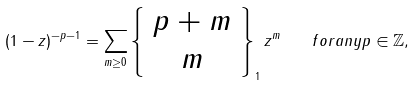Convert formula to latex. <formula><loc_0><loc_0><loc_500><loc_500>( 1 - z ) ^ { - p - 1 } = \sum _ { m \geq 0 } \left \{ \begin{array} { c } p + m \\ m \end{array} \right \} _ { 1 } z ^ { m } \quad f o r a n y p \in { \mathbb { Z } } ,</formula> 